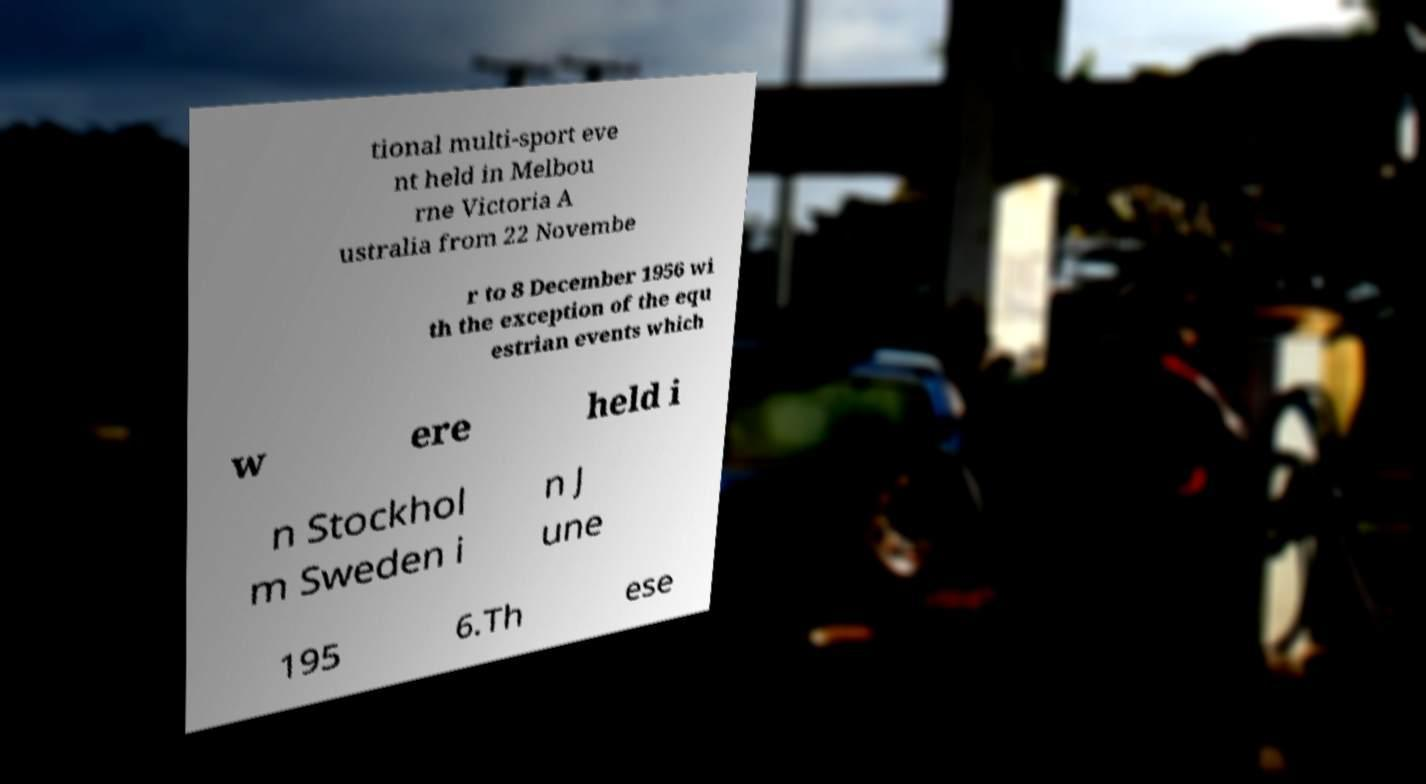Can you accurately transcribe the text from the provided image for me? tional multi-sport eve nt held in Melbou rne Victoria A ustralia from 22 Novembe r to 8 December 1956 wi th the exception of the equ estrian events which w ere held i n Stockhol m Sweden i n J une 195 6.Th ese 